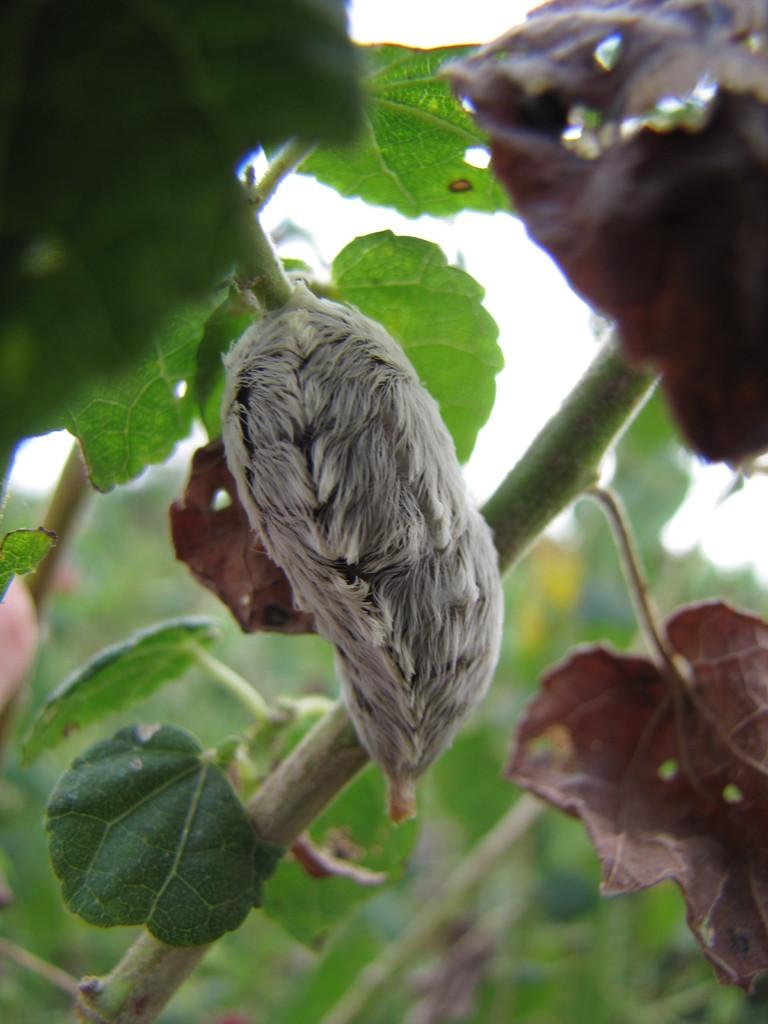What is present on the plant in the image? There is a pest or flower on the plant in the image. What can be seen at the base of the plant? There are leaves visible at the bottom of the plant. What is visible in the background of the image? The sky is visible in the background of the image. What type of coal is being used by the army in the image? There is no army or coal present in the image; it features a plant with a pest or flower and leaves. 